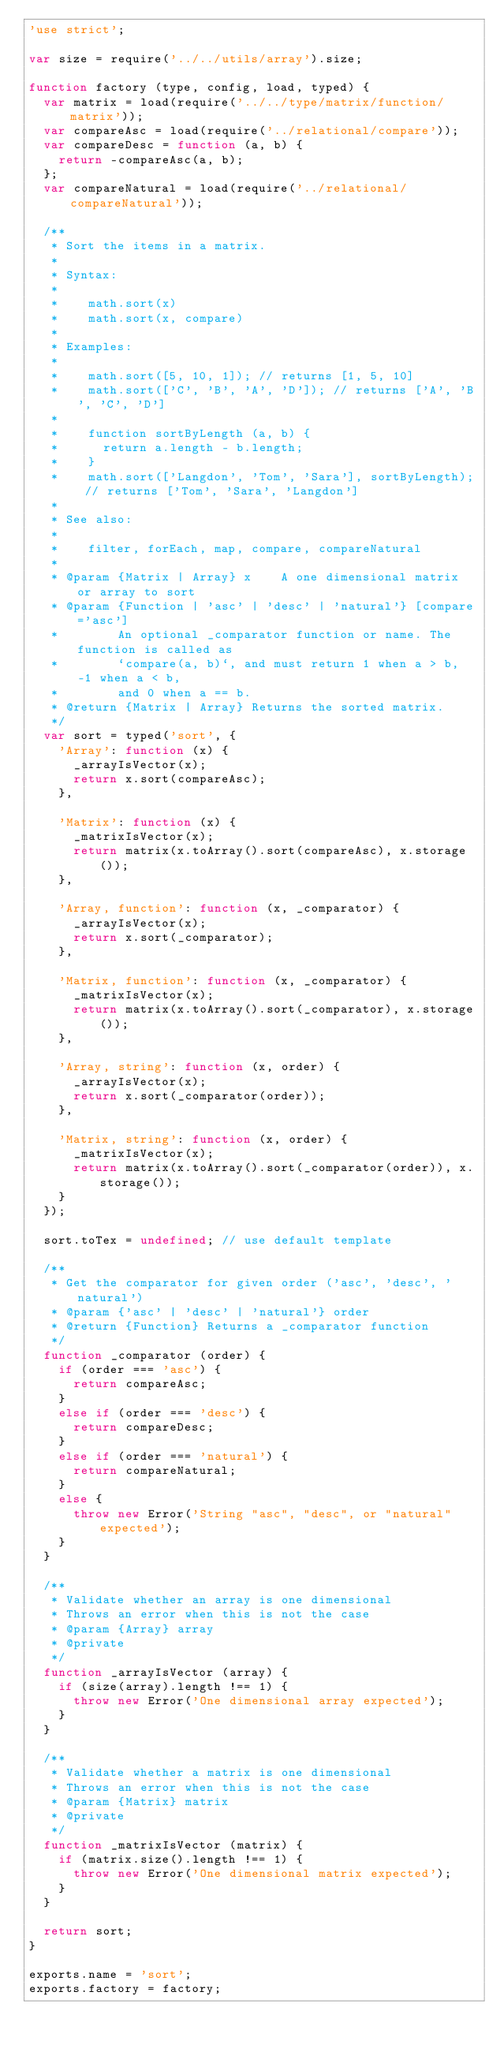Convert code to text. <code><loc_0><loc_0><loc_500><loc_500><_JavaScript_>'use strict';

var size = require('../../utils/array').size;

function factory (type, config, load, typed) {
  var matrix = load(require('../../type/matrix/function/matrix'));
  var compareAsc = load(require('../relational/compare'));
  var compareDesc = function (a, b) {
    return -compareAsc(a, b);
  };
  var compareNatural = load(require('../relational/compareNatural'));

  /**
   * Sort the items in a matrix.
   *
   * Syntax:
   *
   *    math.sort(x)
   *    math.sort(x, compare)
   *
   * Examples:
   *
   *    math.sort([5, 10, 1]); // returns [1, 5, 10]
   *    math.sort(['C', 'B', 'A', 'D']); // returns ['A', 'B', 'C', 'D']
   *
   *    function sortByLength (a, b) {
   *      return a.length - b.length;
   *    }
   *    math.sort(['Langdon', 'Tom', 'Sara'], sortByLength); // returns ['Tom', 'Sara', 'Langdon']
   *
   * See also:
   *
   *    filter, forEach, map, compare, compareNatural
   *
   * @param {Matrix | Array} x    A one dimensional matrix or array to sort
   * @param {Function | 'asc' | 'desc' | 'natural'} [compare='asc']
   *        An optional _comparator function or name. The function is called as
   *        `compare(a, b)`, and must return 1 when a > b, -1 when a < b,
   *        and 0 when a == b.
   * @return {Matrix | Array} Returns the sorted matrix.
   */
  var sort = typed('sort', {
    'Array': function (x) {
      _arrayIsVector(x);
      return x.sort(compareAsc);
    },

    'Matrix': function (x) {
      _matrixIsVector(x);
      return matrix(x.toArray().sort(compareAsc), x.storage());
    },

    'Array, function': function (x, _comparator) {
      _arrayIsVector(x);
      return x.sort(_comparator);
    },

    'Matrix, function': function (x, _comparator) {
      _matrixIsVector(x);
      return matrix(x.toArray().sort(_comparator), x.storage());
    },

    'Array, string': function (x, order) {
      _arrayIsVector(x);
      return x.sort(_comparator(order));
    },

    'Matrix, string': function (x, order) {
      _matrixIsVector(x);
      return matrix(x.toArray().sort(_comparator(order)), x.storage());
    }
  });

  sort.toTex = undefined; // use default template

  /**
   * Get the comparator for given order ('asc', 'desc', 'natural')
   * @param {'asc' | 'desc' | 'natural'} order
   * @return {Function} Returns a _comparator function
   */
  function _comparator (order) {
    if (order === 'asc') {
      return compareAsc;
    }
    else if (order === 'desc') {
      return compareDesc;
    }
    else if (order === 'natural') {
      return compareNatural;
    }
    else {
      throw new Error('String "asc", "desc", or "natural" expected');
    }
  }

  /**
   * Validate whether an array is one dimensional
   * Throws an error when this is not the case
   * @param {Array} array
   * @private
   */
  function _arrayIsVector (array) {
    if (size(array).length !== 1) {
      throw new Error('One dimensional array expected');
    }
  }

  /**
   * Validate whether a matrix is one dimensional
   * Throws an error when this is not the case
   * @param {Matrix} matrix
   * @private
   */
  function _matrixIsVector (matrix) {
    if (matrix.size().length !== 1) {
      throw new Error('One dimensional matrix expected');
    }
  }

  return sort;
}

exports.name = 'sort';
exports.factory = factory;
</code> 